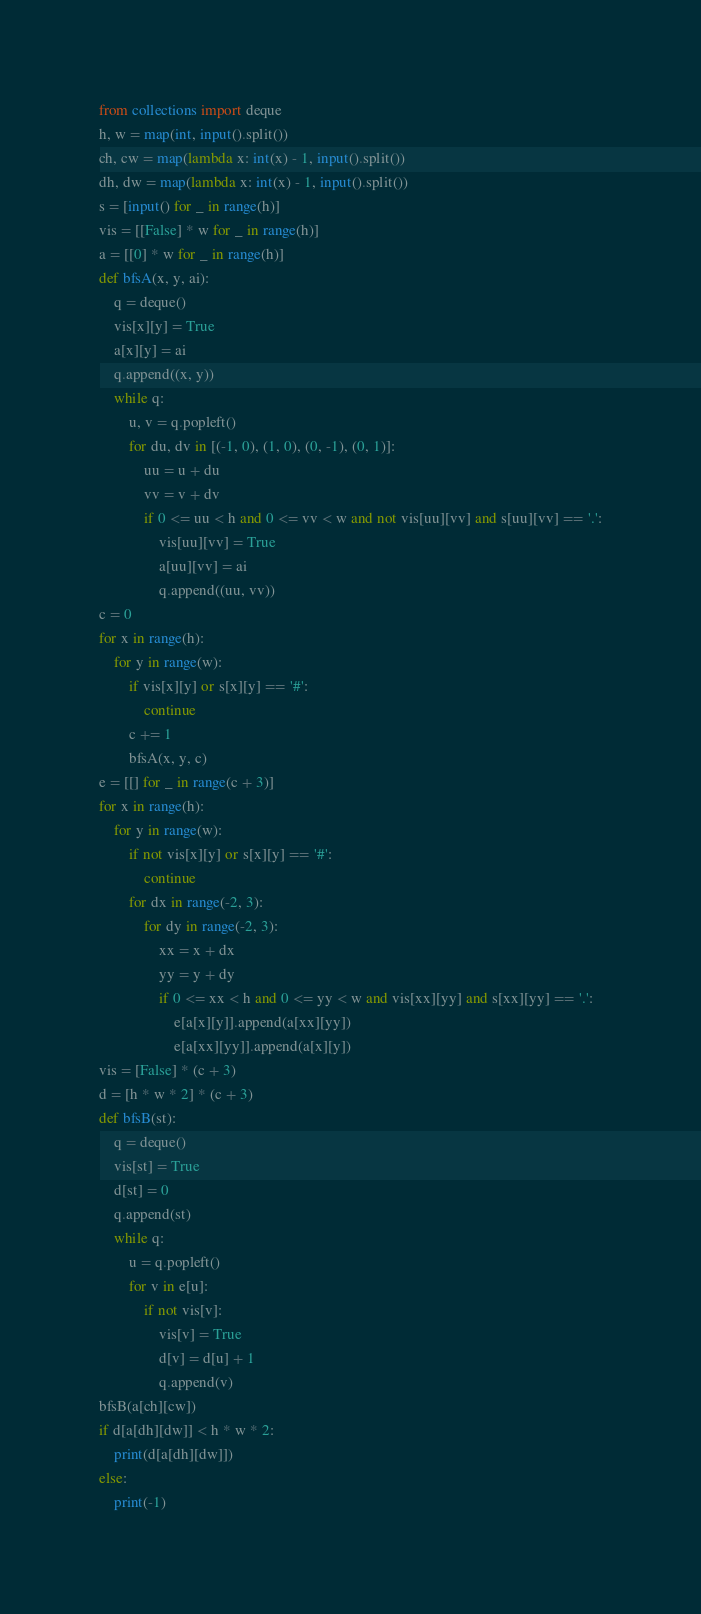<code> <loc_0><loc_0><loc_500><loc_500><_Python_>from collections import deque
h, w = map(int, input().split())
ch, cw = map(lambda x: int(x) - 1, input().split())
dh, dw = map(lambda x: int(x) - 1, input().split())
s = [input() for _ in range(h)]
vis = [[False] * w for _ in range(h)]
a = [[0] * w for _ in range(h)]
def bfsA(x, y, ai):
    q = deque()
    vis[x][y] = True
    a[x][y] = ai
    q.append((x, y))
    while q:
        u, v = q.popleft()
        for du, dv in [(-1, 0), (1, 0), (0, -1), (0, 1)]:
            uu = u + du
            vv = v + dv
            if 0 <= uu < h and 0 <= vv < w and not vis[uu][vv] and s[uu][vv] == '.':
                vis[uu][vv] = True
                a[uu][vv] = ai
                q.append((uu, vv))
c = 0
for x in range(h):
    for y in range(w):
        if vis[x][y] or s[x][y] == '#':
            continue
        c += 1
        bfsA(x, y, c)
e = [[] for _ in range(c + 3)]
for x in range(h):
    for y in range(w):
        if not vis[x][y] or s[x][y] == '#':
            continue
        for dx in range(-2, 3):
            for dy in range(-2, 3):
                xx = x + dx
                yy = y + dy
                if 0 <= xx < h and 0 <= yy < w and vis[xx][yy] and s[xx][yy] == '.':
                    e[a[x][y]].append(a[xx][yy])
                    e[a[xx][yy]].append(a[x][y])
vis = [False] * (c + 3)
d = [h * w * 2] * (c + 3)
def bfsB(st):
    q = deque()
    vis[st] = True
    d[st] = 0
    q.append(st)
    while q:
        u = q.popleft()
        for v in e[u]:
            if not vis[v]:
                vis[v] = True
                d[v] = d[u] + 1
                q.append(v)
bfsB(a[ch][cw])
if d[a[dh][dw]] < h * w * 2:
    print(d[a[dh][dw]])
else:
    print(-1)</code> 